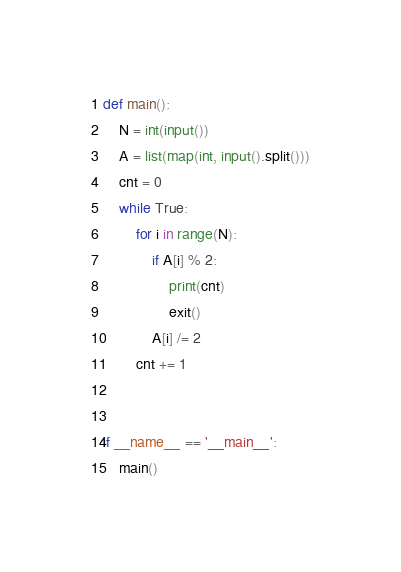Convert code to text. <code><loc_0><loc_0><loc_500><loc_500><_Python_>def main():
    N = int(input())
    A = list(map(int, input().split()))
    cnt = 0
    while True:
        for i in range(N):
            if A[i] % 2:
                print(cnt)
                exit()
            A[i] /= 2
        cnt += 1


if __name__ == '__main__':
    main()</code> 